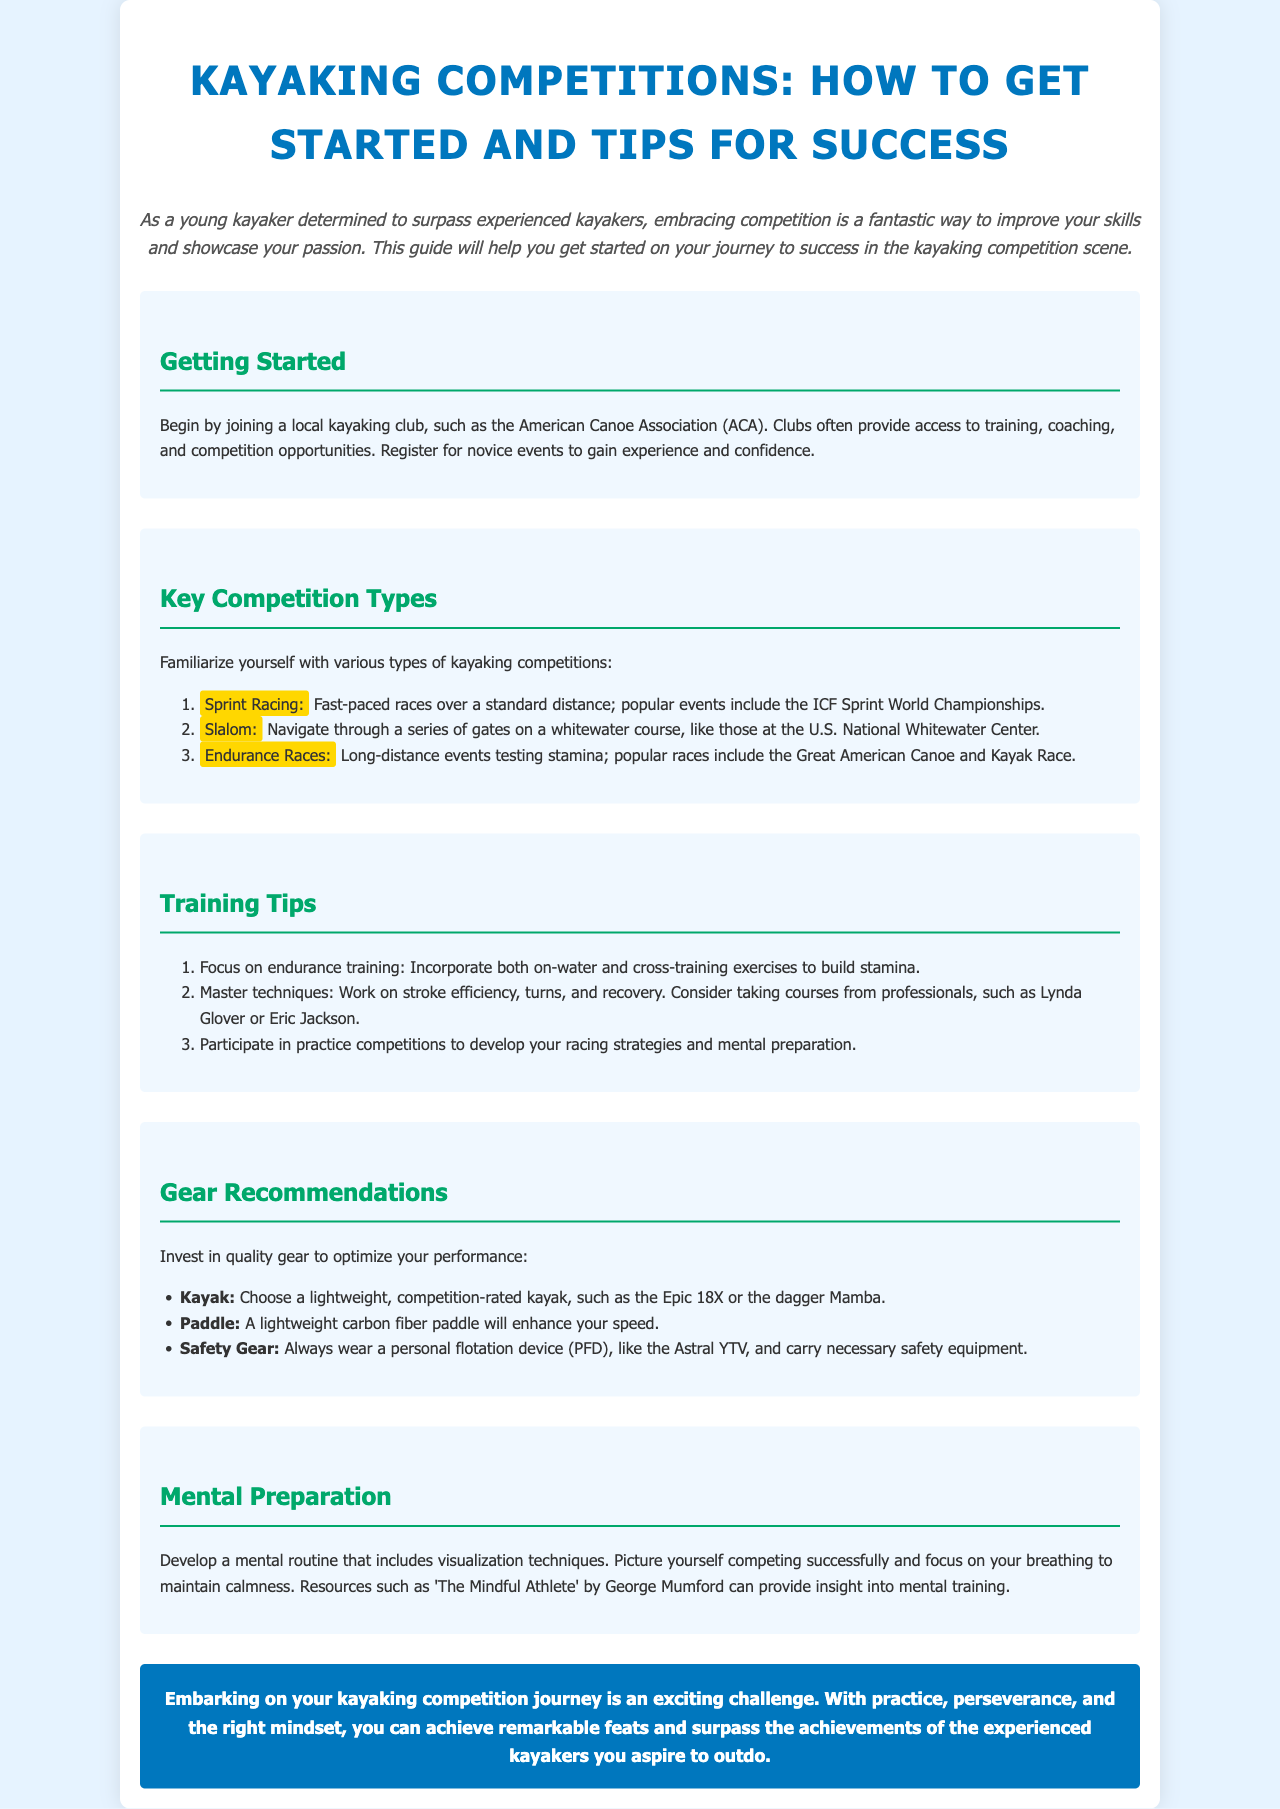What organization should I join to get started in kayaking? The document suggests joining a local kayaking club, such as the American Canoe Association (ACA).
Answer: American Canoe Association (ACA) What are the key types of kayaking competitions mentioned? The document lists Sprint Racing, Slalom, and Endurance Races as the key types of competitions.
Answer: Sprint Racing, Slalom, Endurance Races Which kayak model is recommended for competition? The document recommends choosing a lightweight competition-rated kayak, such as the Epic 18X or the Dagger Mamba.
Answer: Epic 18X or Dagger Mamba What is one of the suggested training tips for kayakers? The document states to focus on endurance training, incorporating both on-water and cross-training exercises to build stamina.
Answer: Focus on endurance training What mental preparation technique is mentioned? The document suggests developing a mental routine that includes visualization techniques.
Answer: Visualization techniques What is the main goal of participating in novice events? The document indicates that participating in novice events helps to gain experience and confidence.
Answer: Gain experience and confidence Who are two professionals mentioned for mastering kayaking techniques? The document mentions considering taking courses from Lynda Glover or Eric Jackson for mastering technique.
Answer: Lynda Glover or Eric Jackson What is the color of the conclusion section? The document describes the conclusion section's background color as blue with white text.
Answer: Blue What type of paddle should I invest in for optimal performance? The document recommends a lightweight carbon fiber paddle to enhance speed.
Answer: Lightweight carbon fiber paddle 